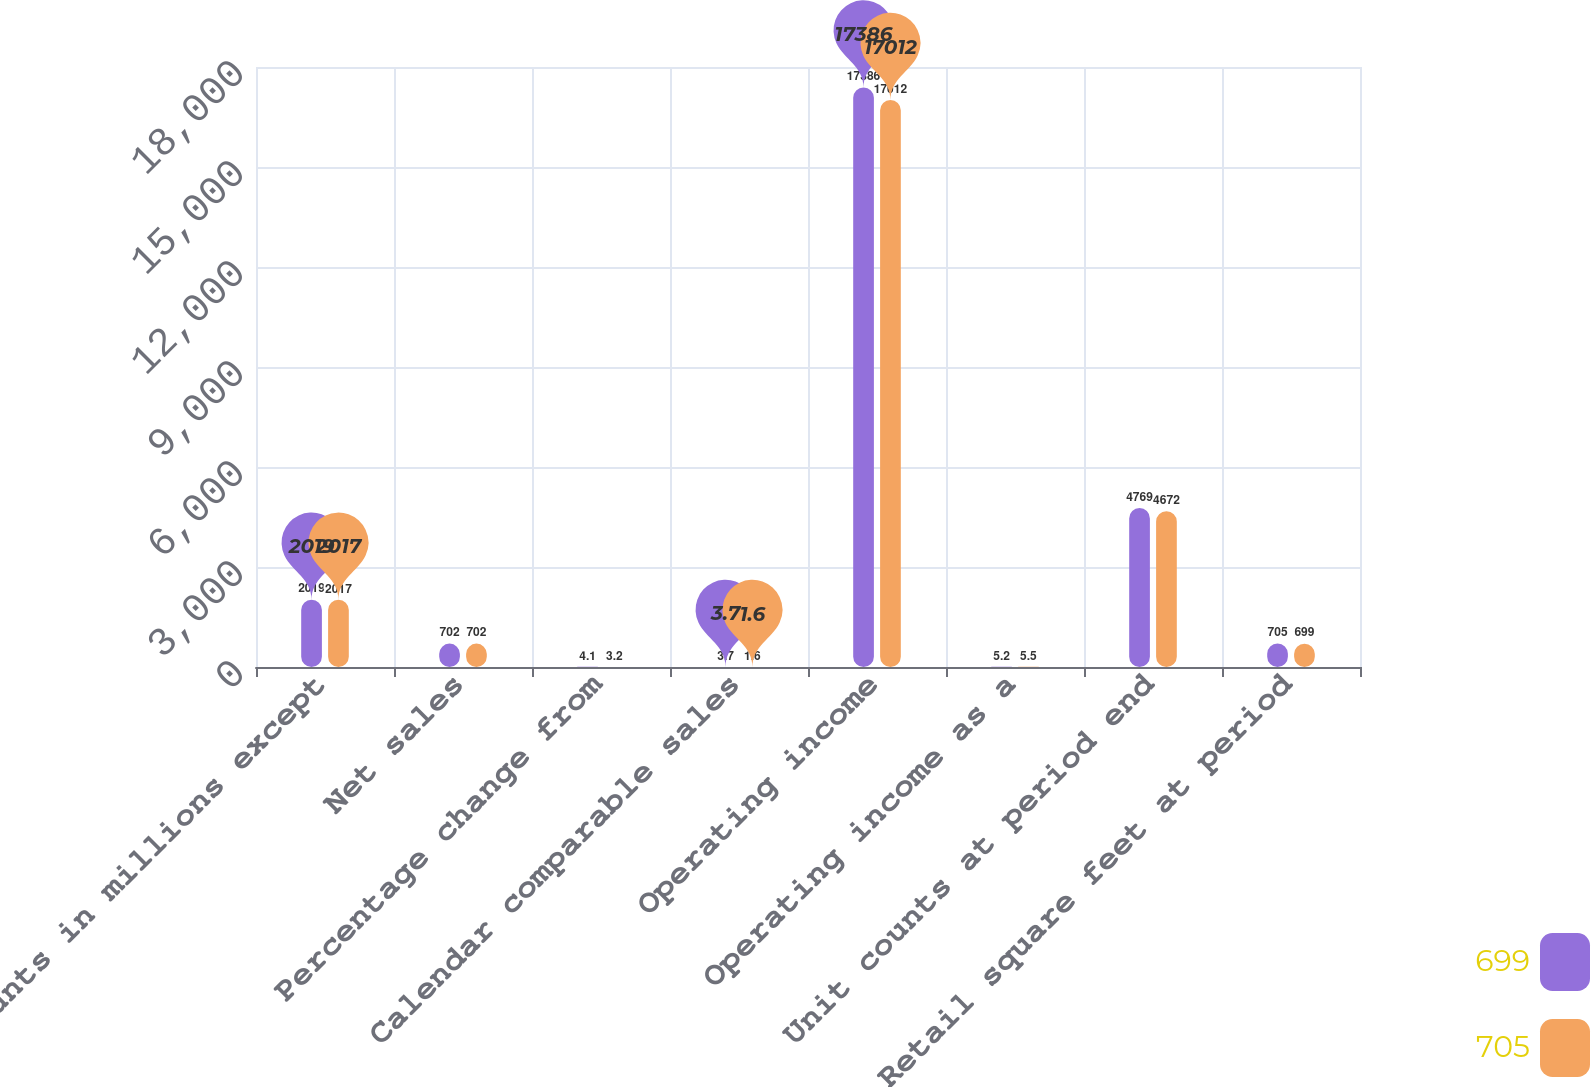Convert chart. <chart><loc_0><loc_0><loc_500><loc_500><stacked_bar_chart><ecel><fcel>(Amounts in millions except<fcel>Net sales<fcel>Percentage change from<fcel>Calendar comparable sales<fcel>Operating income<fcel>Operating income as a<fcel>Unit counts at period end<fcel>Retail square feet at period<nl><fcel>699<fcel>2019<fcel>702<fcel>4.1<fcel>3.7<fcel>17386<fcel>5.2<fcel>4769<fcel>705<nl><fcel>705<fcel>2017<fcel>702<fcel>3.2<fcel>1.6<fcel>17012<fcel>5.5<fcel>4672<fcel>699<nl></chart> 